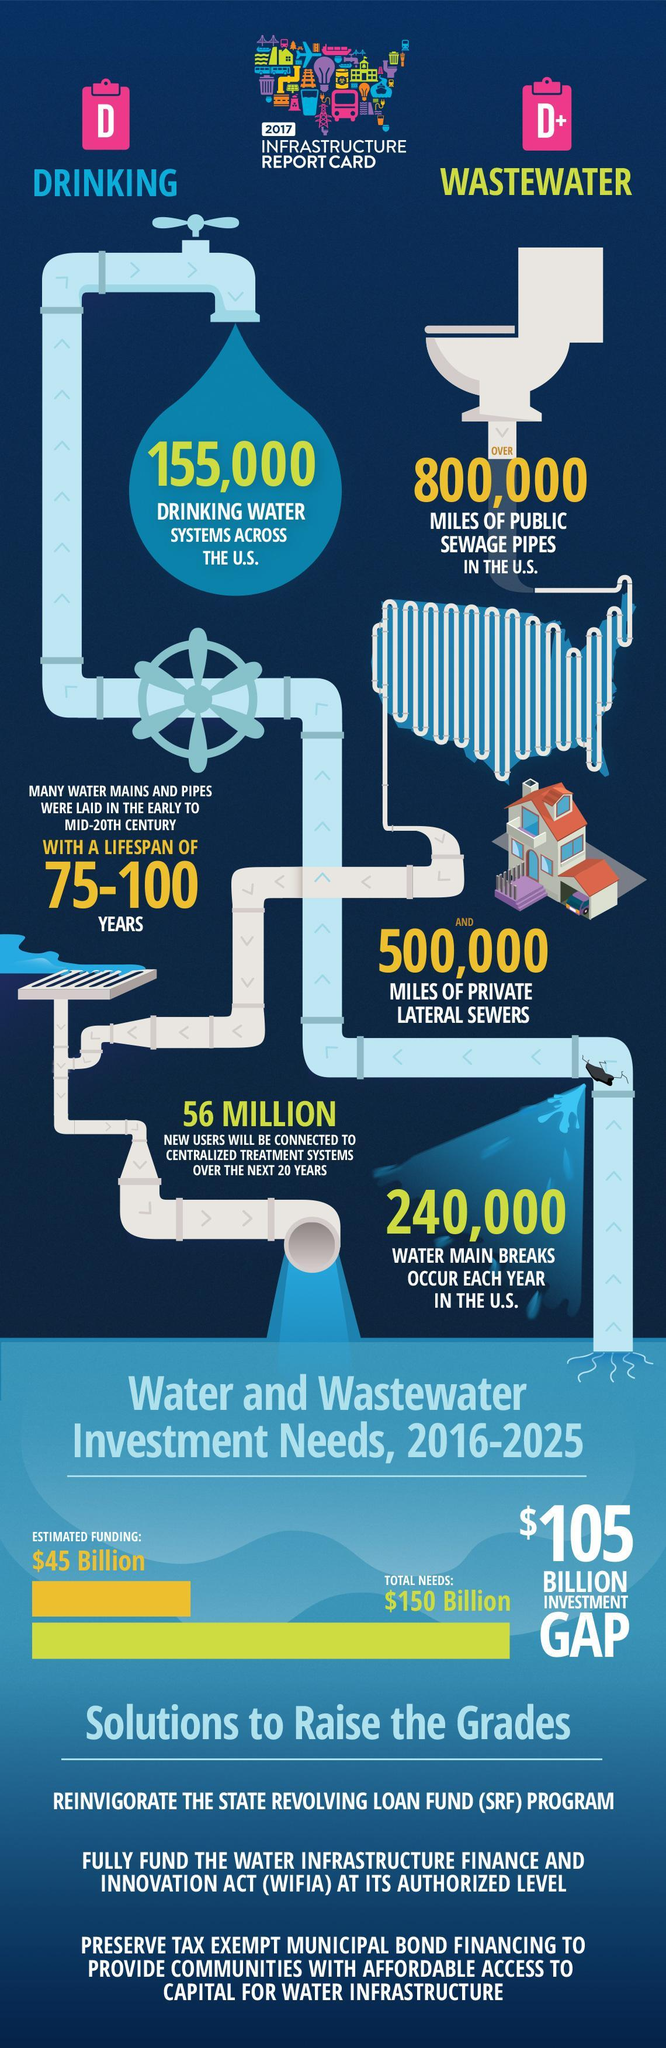How many drinking water systems are there across the U.S. in 2017?
Answer the question with a short phrase. 155,000 